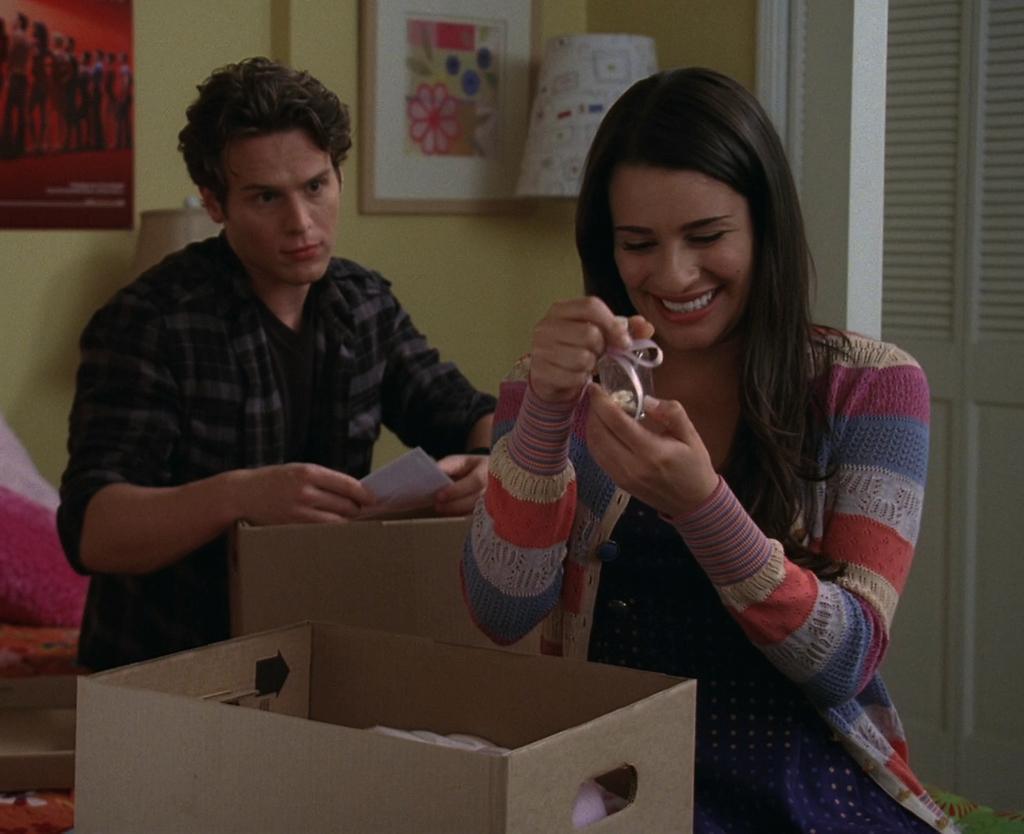Describe this image in one or two sentences. At the bottom of the image we can see some boxes. Behind the boxes two persons are standing and holding something in their hands. Behind them there is wall, on the wall there is a frame and poster and there are some lamps. 